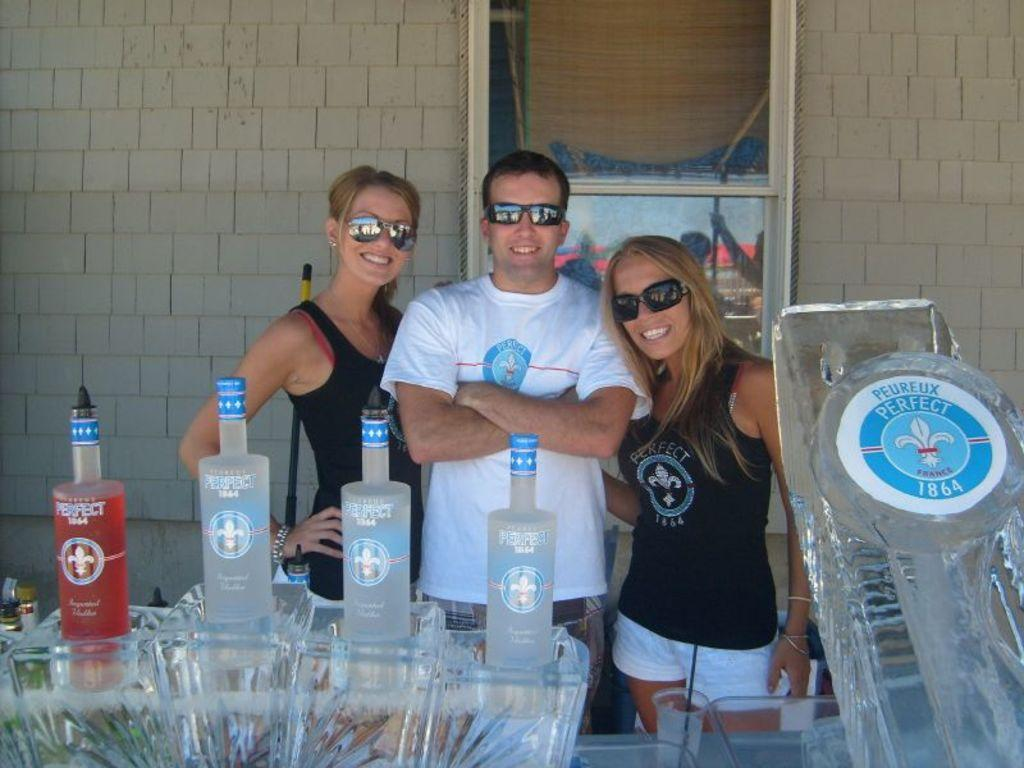How many people are in the image? There is one man and two women in the image. What are the people wearing in the image? The man and women are wearing goggles. What expression do the people have in the image? The man and women are smiling. What objects are in front of the people in the image? There are bottles in front of them. What can be seen in the background of the image? There is a wall and a window in the background of the image. What type of pie is being served to the rabbit in the image? There is no pie or rabbit present in the image. How does the wall in the background support the people in the image? The wall in the background does not support the people in the image; it is a separate element in the background. 